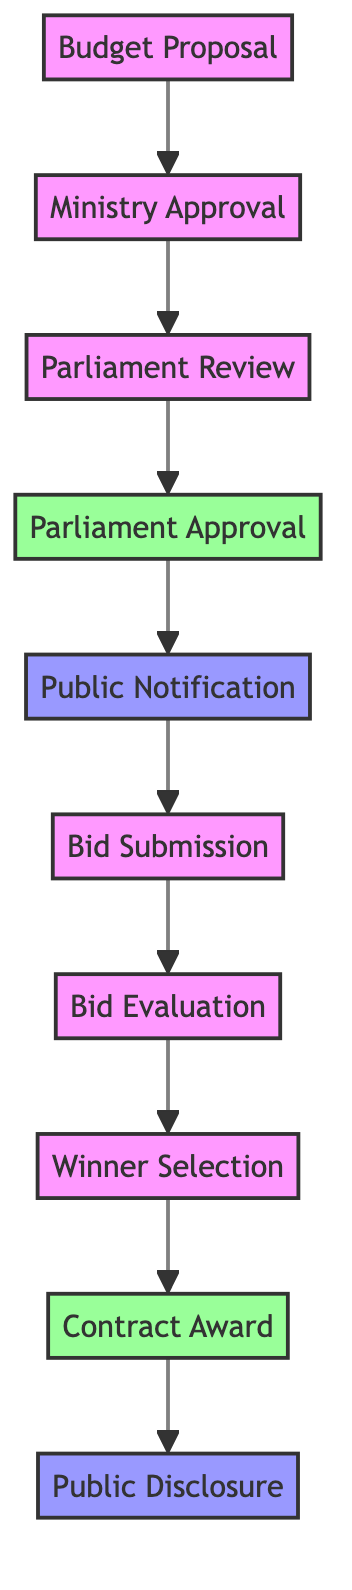What is the first step in the government procurement process? The first step in the diagram is the "Budget Proposal" node, where the initial funding request is initiated. It is the starting point and there are no precedents to this step.
Answer: Budget Proposal How many nodes are there in the diagram? By counting the distinct nodes listed, we find a total of 10 nodes, which represent different stages in the procurement process.
Answer: 10 What is the last step in the process? The last step shown in the diagram is the "Public Disclosure" node, which occurs after the contract is awarded and is crucial for transparency.
Answer: Public Disclosure Which step follows the "Bid Evaluation"? The diagram proceeds from "Bid Evaluation" to "Winner Selection", indicating that once bids are evaluated, a winner is selected based on that evaluation.
Answer: Winner Selection What type of approval comes after the "Parliament Review"? After the "Parliament Review", the next step is the "Parliament Approval", which is a significant milestone where the proposed budget is officially approved before moving on to the public notification stage.
Answer: Parliament Approval How many edges are in the diagram? If we count the connections (or edges) that depict the flow between the nodes, there are 9 edges in total, showing the relationships between each step in the procurement process.
Answer: 9 Which step occurs just before the "Contract Award"? The step that directly precedes the "Contract Award" in the diagram is "Winner Selection", which indicates that the winning bid is determined prior to awarding the contract.
Answer: Winner Selection What node is categorized as "approved" in the diagram? The nodes "Parliament Approval" and "Contract Award" are categorized as "approved", as marked in the diagram with a specific designation indicating their significance in the procurement process.
Answer: Parliament Approval, Contract Award What action is required after "Public Notification"? Following the "Public Notification", the diagram indicates that "Bid Submission" is necessary, which means bidders are invited to submit their proposals for review.
Answer: Bid Submission How does the process flow from the "Winner Selection"? After "Winner Selection", the process flows directly to "Contract Award", showing that the selected winner is then awarded the contract based on the selection.
Answer: Contract Award 